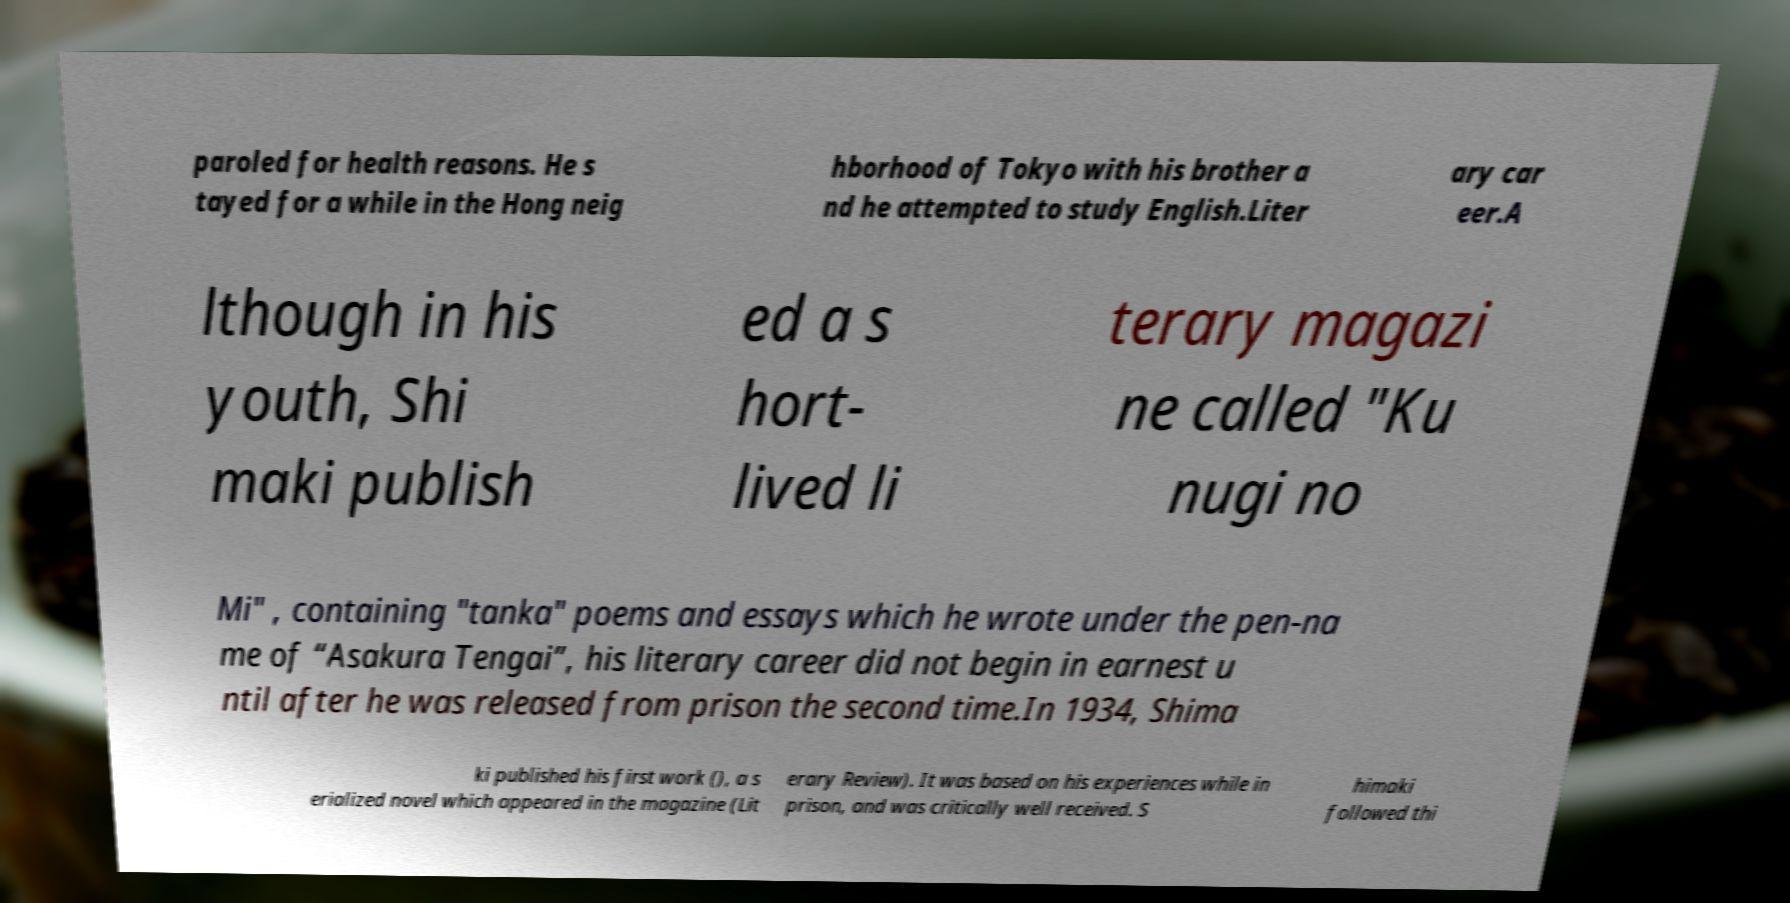Can you accurately transcribe the text from the provided image for me? paroled for health reasons. He s tayed for a while in the Hong neig hborhood of Tokyo with his brother a nd he attempted to study English.Liter ary car eer.A lthough in his youth, Shi maki publish ed a s hort- lived li terary magazi ne called "Ku nugi no Mi" , containing "tanka" poems and essays which he wrote under the pen-na me of “Asakura Tengai”, his literary career did not begin in earnest u ntil after he was released from prison the second time.In 1934, Shima ki published his first work (), a s erialized novel which appeared in the magazine (Lit erary Review). It was based on his experiences while in prison, and was critically well received. S himaki followed thi 